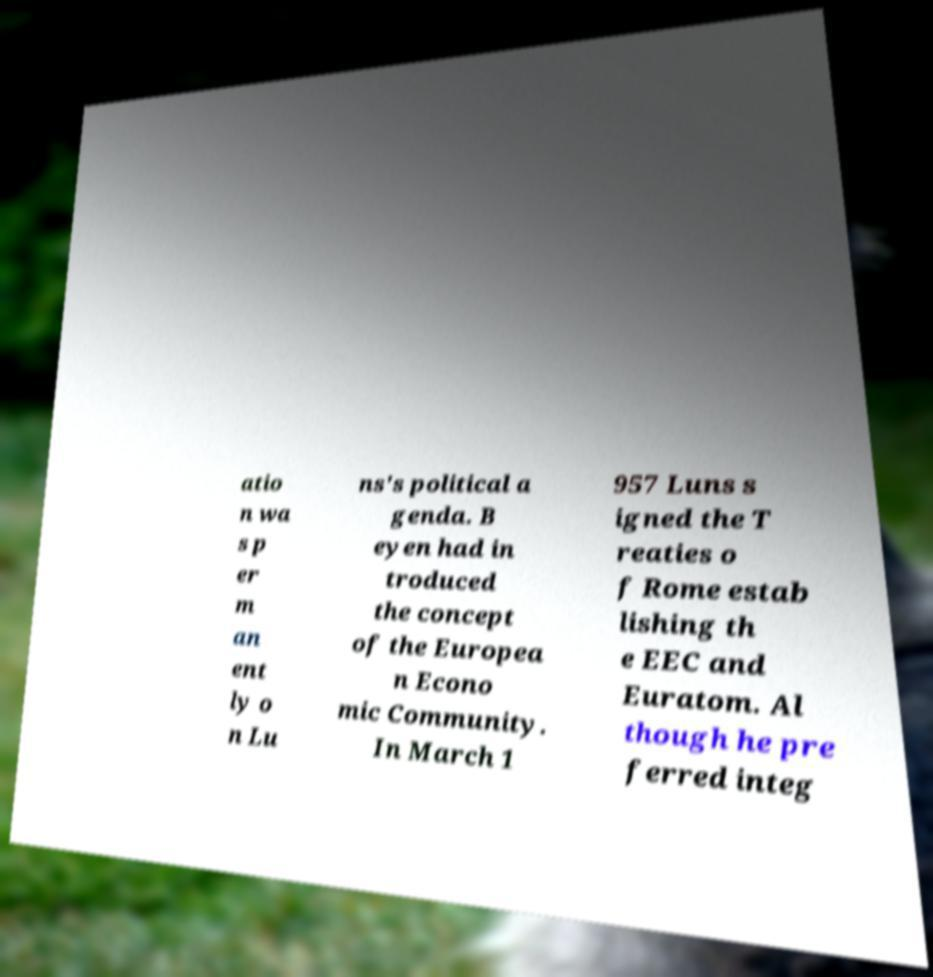For documentation purposes, I need the text within this image transcribed. Could you provide that? atio n wa s p er m an ent ly o n Lu ns's political a genda. B eyen had in troduced the concept of the Europea n Econo mic Community. In March 1 957 Luns s igned the T reaties o f Rome estab lishing th e EEC and Euratom. Al though he pre ferred integ 